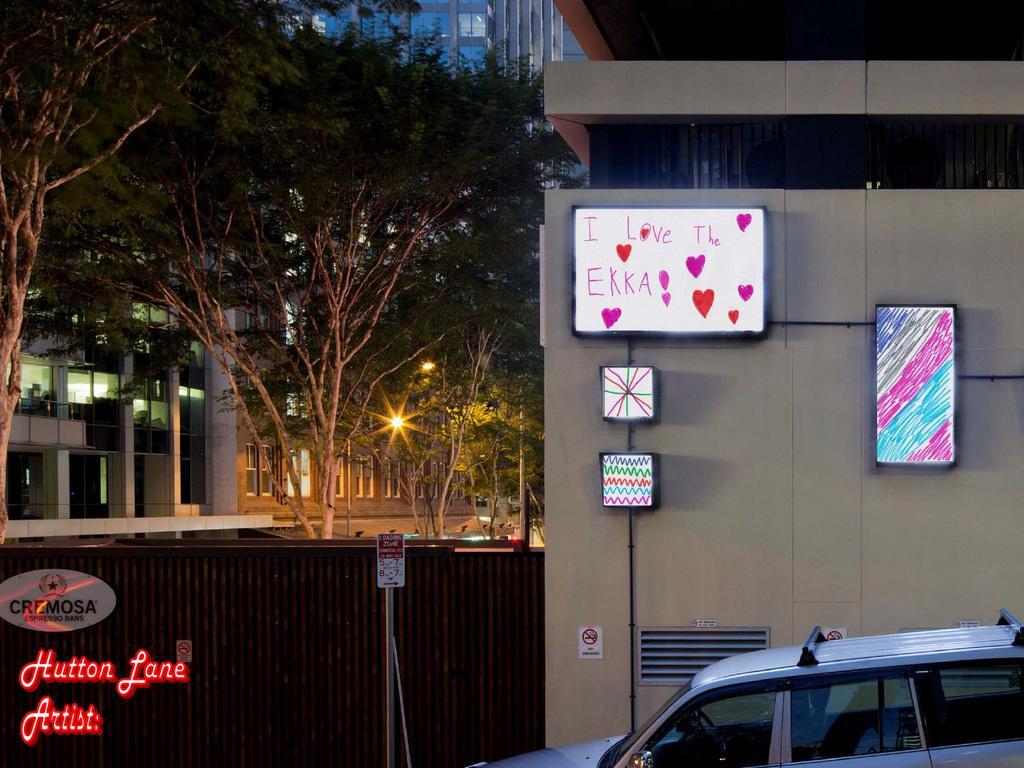Describe this image in one or two sentences. In this picture there is a vehicle in the right corner and there is a wall beside it which has few paintings and something written on it and there are trees and buildings in the background. 